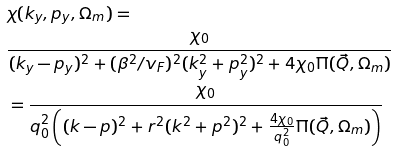<formula> <loc_0><loc_0><loc_500><loc_500>& \chi ( k _ { y } , p _ { y } , \Omega _ { m } ) = \\ & \frac { \chi _ { 0 } } { ( k _ { y } - p _ { y } ) ^ { 2 } + ( \beta ^ { 2 } / v _ { F } ) ^ { 2 } ( k _ { y } ^ { 2 } + p _ { y } ^ { 2 } ) ^ { 2 } + 4 \chi _ { 0 } \Pi ( \vec { Q } , \Omega _ { m } ) } \\ & = \frac { \chi _ { 0 } } { q _ { 0 } ^ { 2 } \left ( ( k - p ) ^ { 2 } + r ^ { 2 } ( k ^ { 2 } + p ^ { 2 } ) ^ { 2 } + \frac { 4 \chi _ { 0 } } { q _ { 0 } ^ { 2 } } \Pi ( \vec { Q } , \Omega _ { m } ) \right ) }</formula> 